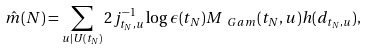<formula> <loc_0><loc_0><loc_500><loc_500>\hat { m } ( N ) = \sum _ { u | U ( t _ { N } ) } 2 j _ { t _ { N } , u } ^ { - 1 } \log { \epsilon ( t _ { N } ) } M _ { \ G a m } ( t _ { N } , u ) h ( d _ { t _ { N } , u } ) ,</formula> 